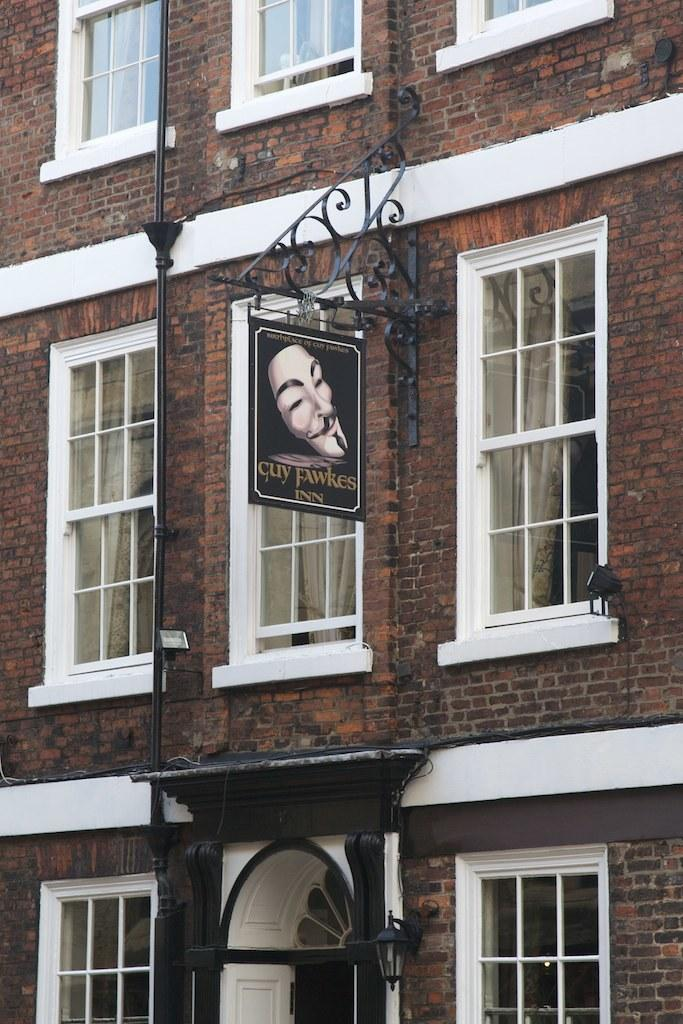What type of structure is visible in the image? There is a building in the image. What is located in the center of the image? There is a board in the center of the image. What other object can be seen in the image? There is a pipe in the image. What feature allows light to enter the building? There are windows in the image. Can you describe the lighting conditions in the image? There is light in the image. What type of thunder can be heard in the image? There is no sound present in the image, so it is not thunder cannot be heard. 